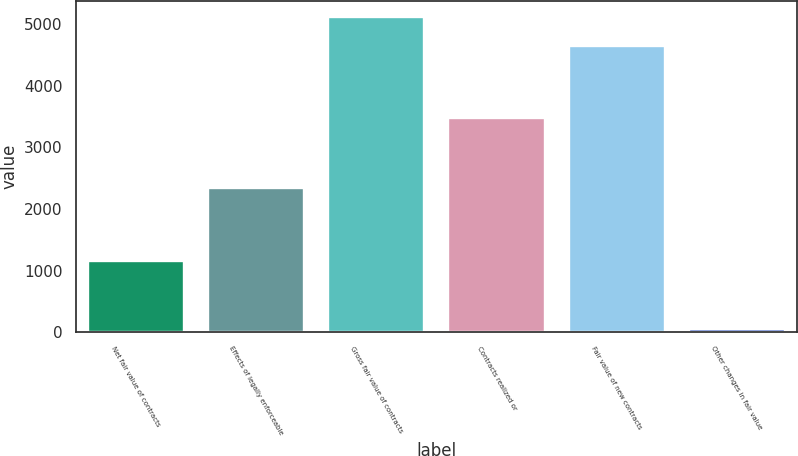Convert chart to OTSL. <chart><loc_0><loc_0><loc_500><loc_500><bar_chart><fcel>Net fair value of contracts<fcel>Effects of legally enforceable<fcel>Gross fair value of contracts<fcel>Contracts realized or<fcel>Fair value of new contracts<fcel>Other changes in fair value<nl><fcel>1148<fcel>2339<fcel>5112.2<fcel>3477<fcel>4646<fcel>59<nl></chart> 